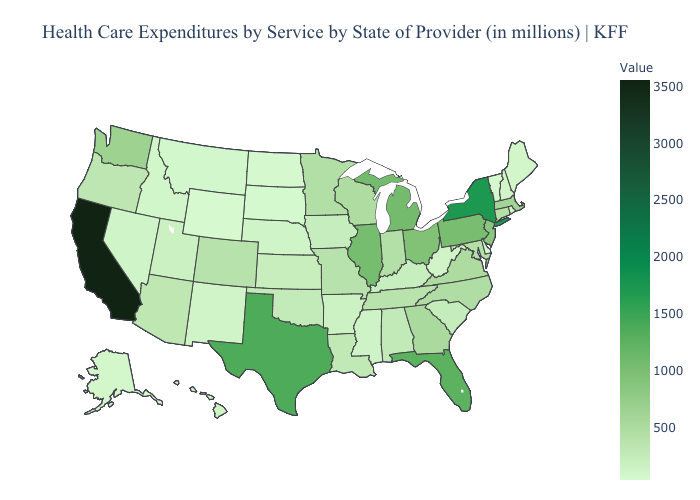Among the states that border Wisconsin , which have the lowest value?
Write a very short answer. Iowa. Among the states that border Kentucky , which have the highest value?
Quick response, please. Illinois. Does North Carolina have the highest value in the USA?
Quick response, please. No. Among the states that border South Dakota , does Wyoming have the lowest value?
Give a very brief answer. Yes. Does California have the highest value in the USA?
Be succinct. Yes. Does North Dakota have the lowest value in the USA?
Answer briefly. No. Does Maine have a higher value than Ohio?
Keep it brief. No. Which states have the lowest value in the West?
Short answer required. Wyoming. Does Wisconsin have a lower value than Delaware?
Be succinct. No. 